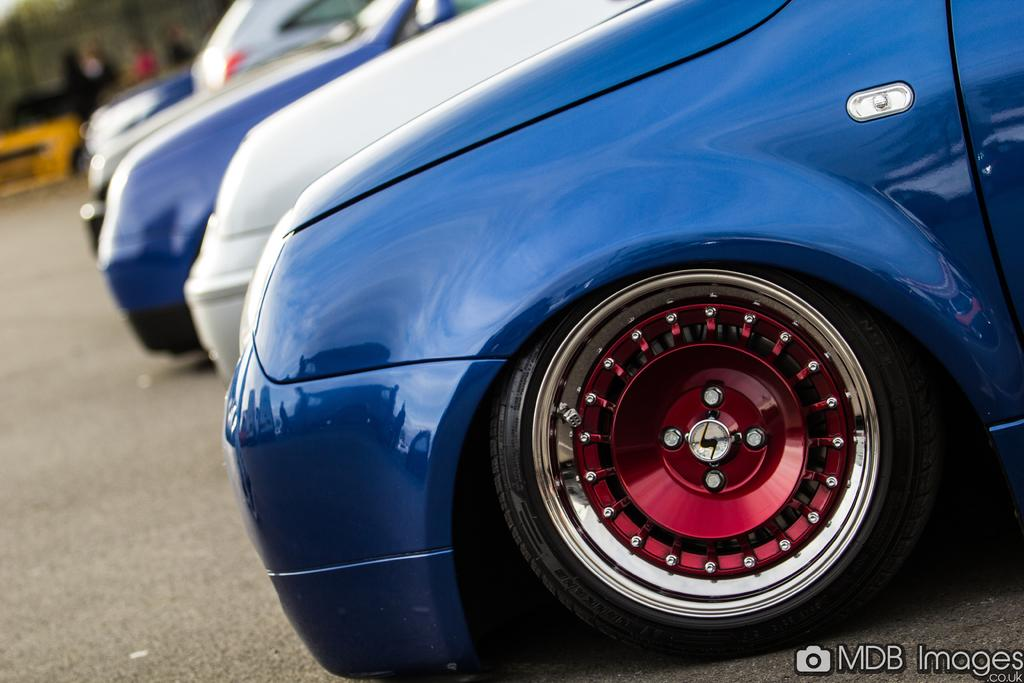What can be seen on the road in the image? There are cars on the road in the image. What else is visible in the image besides the cars? There are people visible in the background of the image, as well as some text and a logo at the bottom of the image. How many eyes can be seen on the cars in the image? Cars do not have eyes, so this question cannot be answered based on the information provided. 